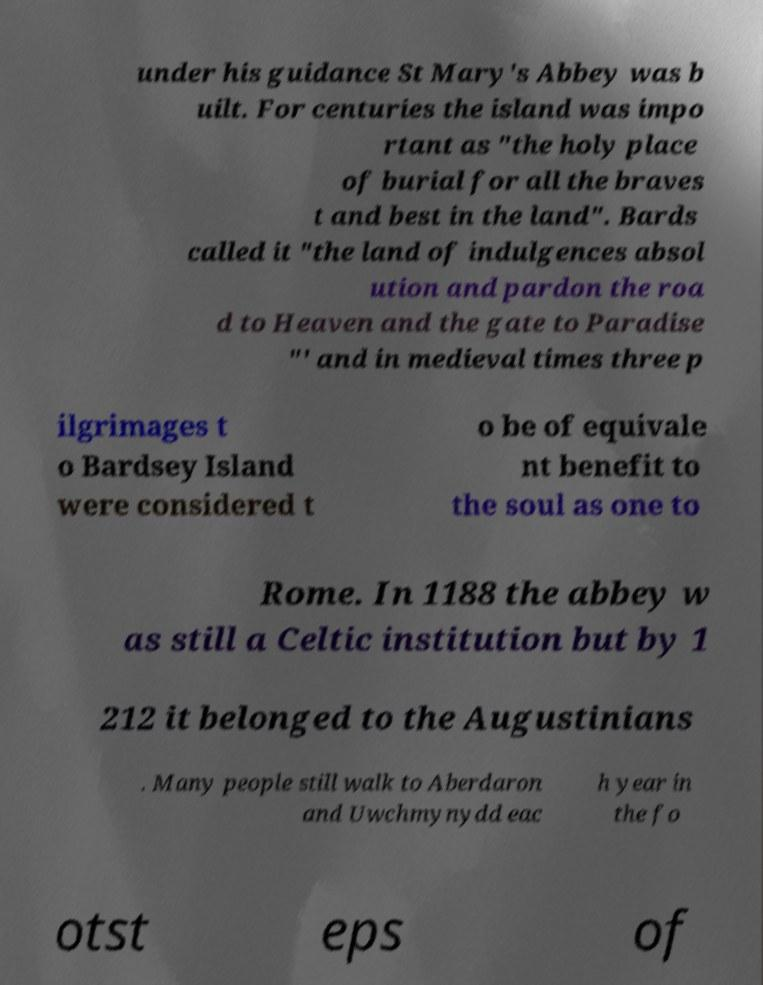Could you assist in decoding the text presented in this image and type it out clearly? under his guidance St Mary's Abbey was b uilt. For centuries the island was impo rtant as "the holy place of burial for all the braves t and best in the land". Bards called it "the land of indulgences absol ution and pardon the roa d to Heaven and the gate to Paradise "' and in medieval times three p ilgrimages t o Bardsey Island were considered t o be of equivale nt benefit to the soul as one to Rome. In 1188 the abbey w as still a Celtic institution but by 1 212 it belonged to the Augustinians . Many people still walk to Aberdaron and Uwchmynydd eac h year in the fo otst eps of 